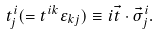<formula> <loc_0><loc_0><loc_500><loc_500>t _ { j } ^ { i } ( = t ^ { i k } \varepsilon _ { k j } ) \equiv i \vec { t } \cdot \vec { \sigma } _ { j } ^ { i } .</formula> 